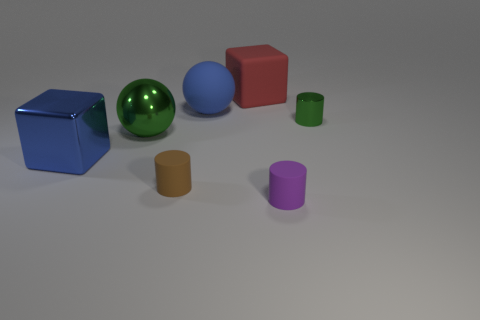Subtract all metal cylinders. How many cylinders are left? 2 Subtract all purple cylinders. How many cylinders are left? 2 Subtract 2 cylinders. How many cylinders are left? 1 Add 2 green metallic things. How many green metallic things exist? 4 Add 3 purple matte objects. How many objects exist? 10 Subtract 0 cyan cylinders. How many objects are left? 7 Subtract all spheres. How many objects are left? 5 Subtract all red cubes. Subtract all cyan spheres. How many cubes are left? 1 Subtract all yellow blocks. How many brown cylinders are left? 1 Subtract all yellow metallic cylinders. Subtract all large blue matte balls. How many objects are left? 6 